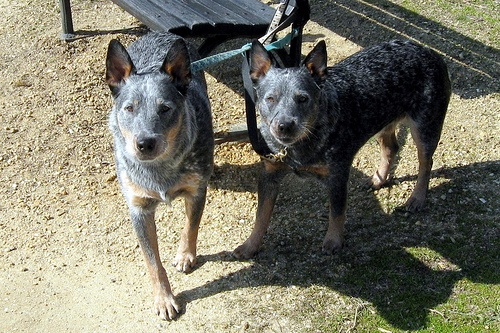Describe the objects in this image and their specific colors. I can see dog in beige, black, gray, and darkgray tones, dog in beige, black, gray, lightgray, and darkgray tones, and bench in beige, black, and gray tones in this image. 